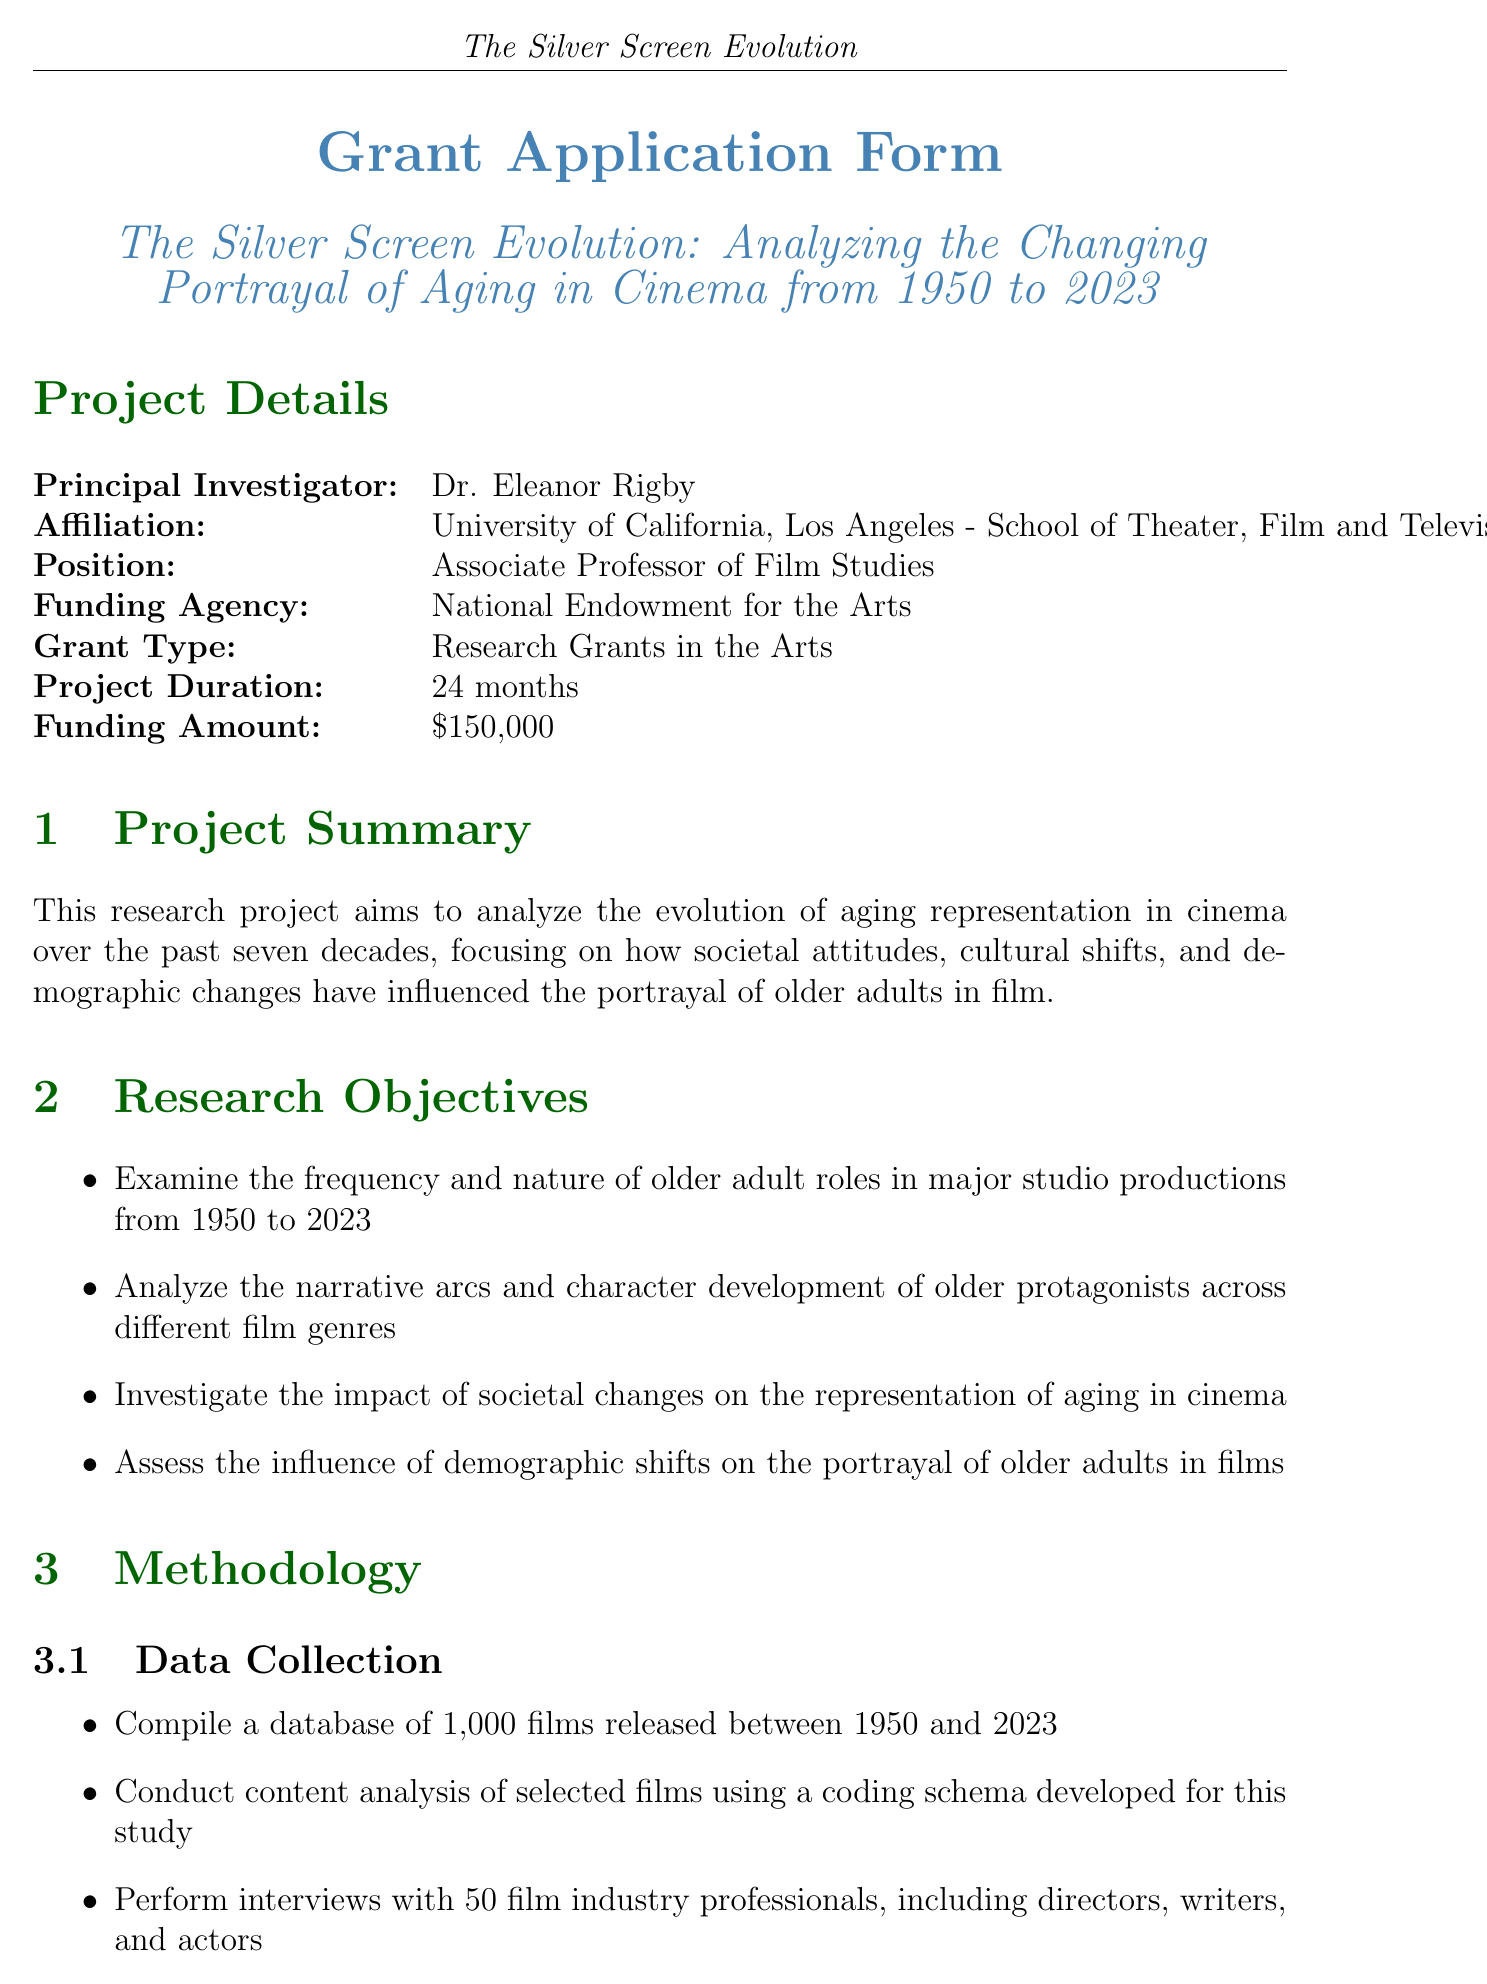What is the title of the project? The title of the project is a critical identifying information for this research, which is provided at the beginning of the document.
Answer: The Silver Screen Evolution: Analyzing the Changing Portrayal of Aging in Cinema from 1950 to 2023 Who is the Principal Investigator? The Principal Investigator is the main researcher leading the project, specified in the project details section.
Answer: Dr. Eleanor Rigby What is the expected funding amount? The expected funding amount is stated explicitly in the project details, providing insight into the financial resources required for the study.
Answer: $150,000 How long is the project duration? The project duration gives an overview of the timeline for this research initiative, especially important for understanding the scope and scale of the project.
Answer: 24 months What is one of the research objectives? Identifying a specific research objective illustrates the goals and focus areas of the project, highlighting its significance in film studies.
Answer: Examine the frequency and nature of older adult roles in major studio productions from 1950 to 2023 How many films will be compiled for analysis? This question emphasizes the scale of the data collection phase in the research methodology, revealing the breadth of the research effort.
Answer: 1,000 films What software will be used for data analysis? Knowing the software to be utilized in data analysis provides insight into the methodological rigor and tools that will be employed in the study.
Answer: NVivo Who is serving as the industry consultant? Identifying the industry consultant offers context regarding the expertise that will guide practical aspects of the research, enhancing the reliability of findings.
Answer: Jane Fonda What is one expected outcome of the project? Highlighting an expected outcome shows the anticipated impact and contributions of the research to the field of film studies, reflecting its significance.
Answer: A comprehensive report on the evolution of aging representation in cinema from 1950 to 2023 